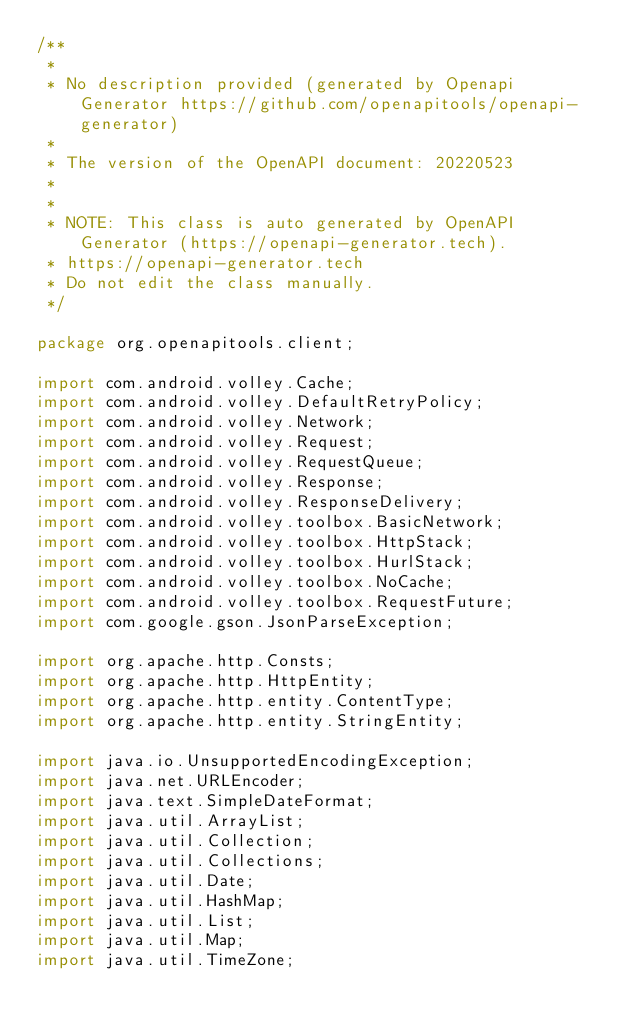Convert code to text. <code><loc_0><loc_0><loc_500><loc_500><_Java_>/**
 * 
 * No description provided (generated by Openapi Generator https://github.com/openapitools/openapi-generator)
 *
 * The version of the OpenAPI document: 20220523
 * 
 *
 * NOTE: This class is auto generated by OpenAPI Generator (https://openapi-generator.tech).
 * https://openapi-generator.tech
 * Do not edit the class manually.
 */

package org.openapitools.client;

import com.android.volley.Cache;
import com.android.volley.DefaultRetryPolicy;
import com.android.volley.Network;
import com.android.volley.Request;
import com.android.volley.RequestQueue;
import com.android.volley.Response;
import com.android.volley.ResponseDelivery;
import com.android.volley.toolbox.BasicNetwork;
import com.android.volley.toolbox.HttpStack;
import com.android.volley.toolbox.HurlStack;
import com.android.volley.toolbox.NoCache;
import com.android.volley.toolbox.RequestFuture;
import com.google.gson.JsonParseException;

import org.apache.http.Consts;
import org.apache.http.HttpEntity;
import org.apache.http.entity.ContentType;
import org.apache.http.entity.StringEntity;

import java.io.UnsupportedEncodingException;
import java.net.URLEncoder;
import java.text.SimpleDateFormat;
import java.util.ArrayList;
import java.util.Collection;
import java.util.Collections;
import java.util.Date;
import java.util.HashMap;
import java.util.List;
import java.util.Map;
import java.util.TimeZone;</code> 